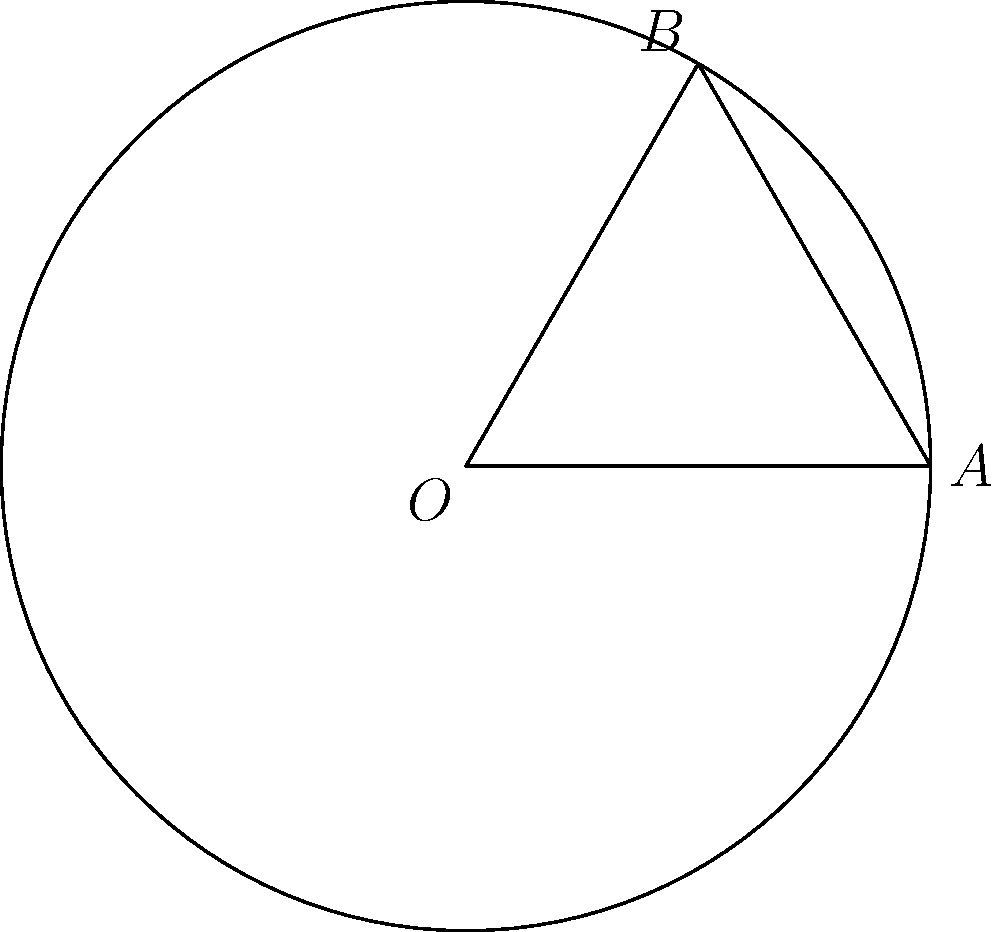A laser beam for tattoo removal covers a circular area on flat skin. When applied to a curved surface like an arm, the beam forms an arc. If the arm has a radius of curvature of 6 cm and the laser beam covers an arc of 60°, what is the length of the arc covered by the laser on the skin surface? Round your answer to the nearest millimeter. To solve this problem, we'll use the formula for arc length:

$s = r\theta$

Where:
$s$ = arc length
$r$ = radius of curvature
$\theta$ = central angle in radians

Steps:
1) We're given the radius $r = 6$ cm and the angle $\theta = 60°$.

2) Convert the angle from degrees to radians:
   $\theta = 60° \times \frac{\pi}{180°} = \frac{\pi}{3}$ radians

3) Apply the arc length formula:
   $s = r\theta = 6 \times \frac{\pi}{3} = 2\pi$ cm

4) Convert to millimeters:
   $2\pi$ cm $= 2\pi \times 10$ mm $\approx 62.8$ mm

5) Rounding to the nearest millimeter:
   $62.8$ mm rounds to $63$ mm

Therefore, the length of the arc covered by the laser on the skin surface is approximately 63 mm.
Answer: 63 mm 